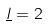Convert formula to latex. <formula><loc_0><loc_0><loc_500><loc_500>\underline { l } = 2</formula> 